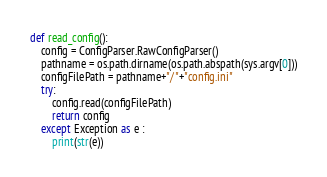<code> <loc_0><loc_0><loc_500><loc_500><_Python_>
def read_config():
    config = ConfigParser.RawConfigParser()
    pathname = os.path.dirname(os.path.abspath(sys.argv[0]))
    configFilePath = pathname+"/"+"config.ini"
    try:
        config.read(configFilePath)
        return config
    except Exception as e :
        print(str(e))</code> 